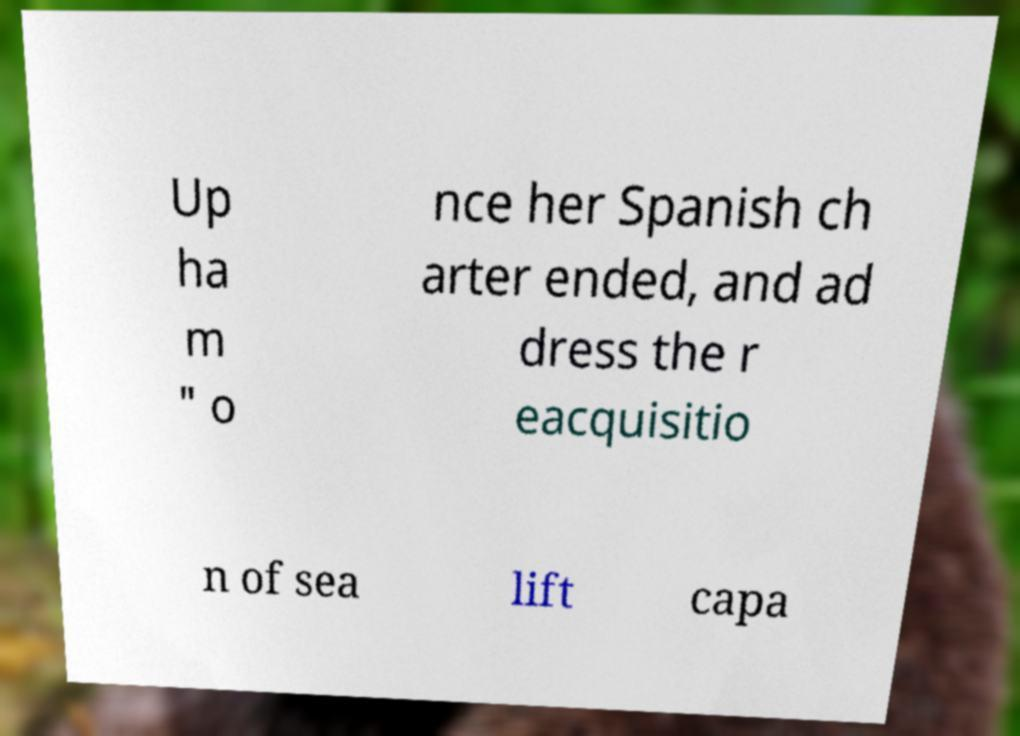For documentation purposes, I need the text within this image transcribed. Could you provide that? Up ha m " o nce her Spanish ch arter ended, and ad dress the r eacquisitio n of sea lift capa 